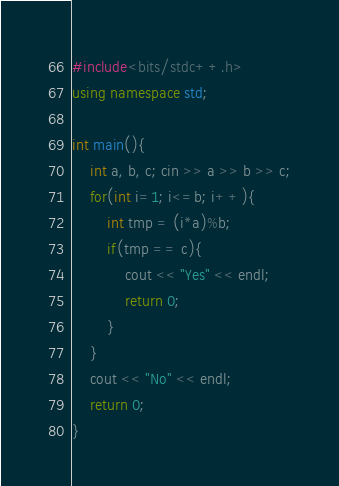<code> <loc_0><loc_0><loc_500><loc_500><_C++_>#include<bits/stdc++.h>
using namespace std;

int main(){
    int a, b, c; cin >> a >> b >> c;
    for(int i=1; i<=b; i++){
        int tmp = (i*a)%b;
        if(tmp == c){
            cout << "Yes" << endl;
            return 0;
        }
    }
    cout << "No" << endl;
    return 0;
}</code> 